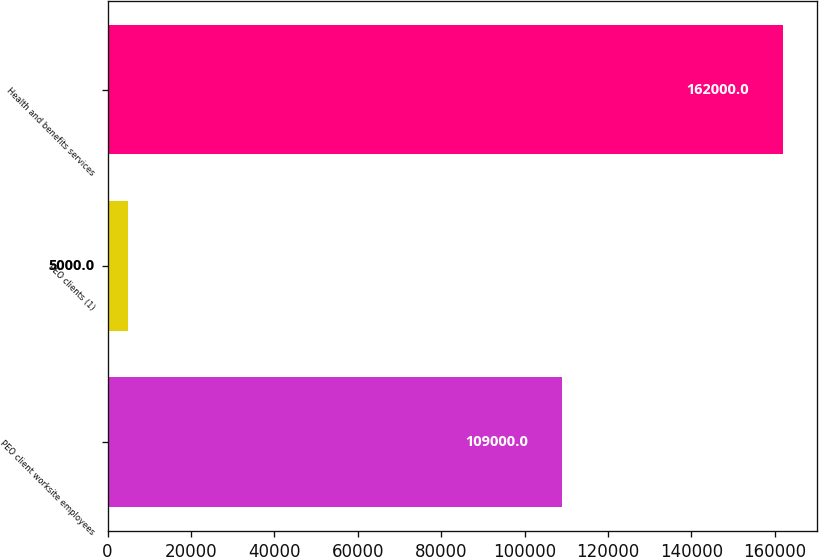Convert chart to OTSL. <chart><loc_0><loc_0><loc_500><loc_500><bar_chart><fcel>PEO client worksite employees<fcel>PEO clients (1)<fcel>Health and benefits services<nl><fcel>109000<fcel>5000<fcel>162000<nl></chart> 